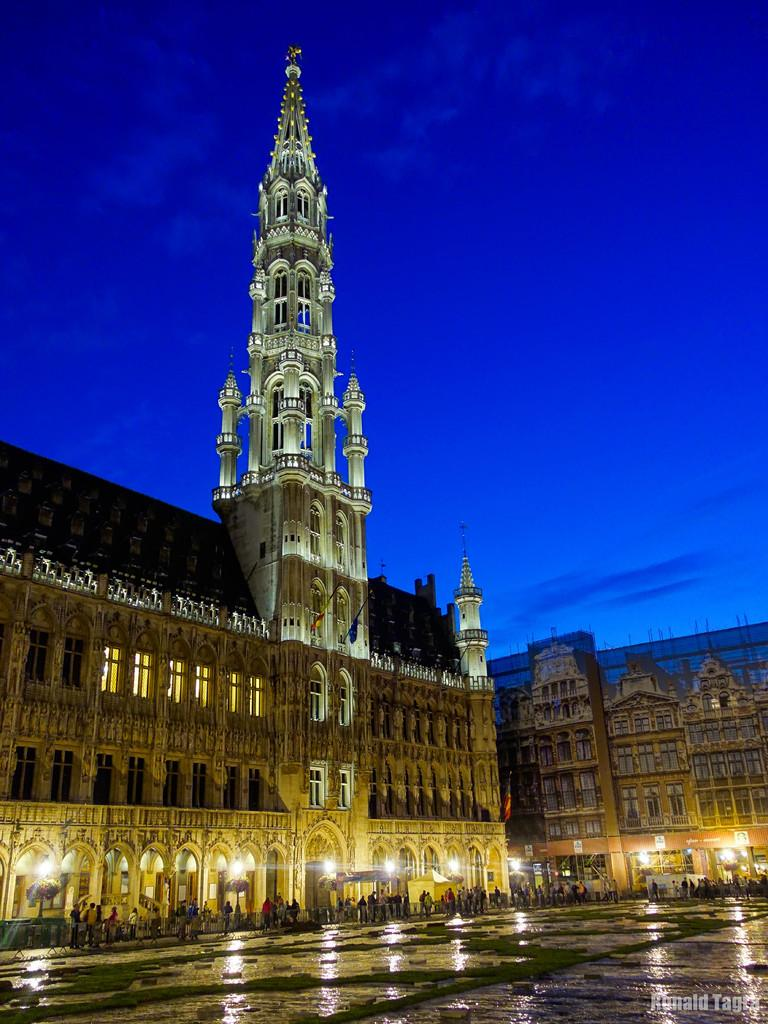What type of structure is present in the image? There is a building in the image. What features can be observed on the building? The building has windows, a roof, and lights. What is happening in the image besides the building? There are people walking on a pathway in the image. What can be seen in the sky in the image? The sky is visible in the image, and it appears cloudy. What type of rake is being used to clear the snow in the image? There is no rake or snow present in the image; it features a building with people walking on a pathway and a cloudy sky. 